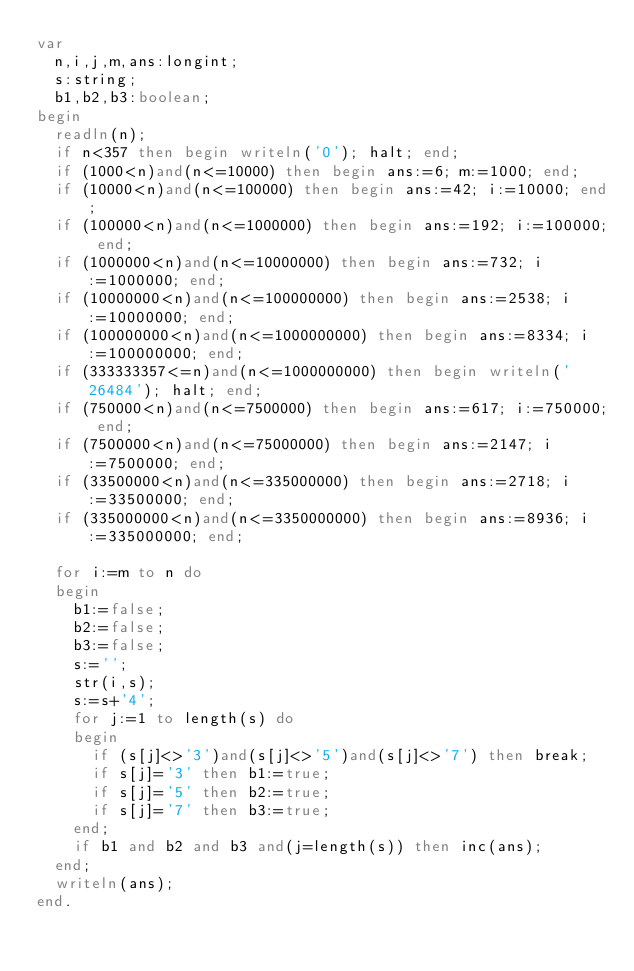Convert code to text. <code><loc_0><loc_0><loc_500><loc_500><_Pascal_>var
  n,i,j,m,ans:longint;
  s:string;
  b1,b2,b3:boolean;
begin
  readln(n);
  if n<357 then begin writeln('0'); halt; end;
  if (1000<n)and(n<=10000) then begin ans:=6; m:=1000; end;
  if (10000<n)and(n<=100000) then begin ans:=42; i:=10000; end;
  if (100000<n)and(n<=1000000) then begin ans:=192; i:=100000; end;
  if (1000000<n)and(n<=10000000) then begin ans:=732; i:=1000000; end;
  if (10000000<n)and(n<=100000000) then begin ans:=2538; i:=10000000; end;
  if (100000000<n)and(n<=1000000000) then begin ans:=8334; i:=100000000; end;
  if (333333357<=n)and(n<=1000000000) then begin writeln('26484'); halt; end;
  if (750000<n)and(n<=7500000) then begin ans:=617; i:=750000; end;
  if (7500000<n)and(n<=75000000) then begin ans:=2147; i:=7500000; end;
  if (33500000<n)and(n<=335000000) then begin ans:=2718; i:=33500000; end;
  if (335000000<n)and(n<=3350000000) then begin ans:=8936; i:=335000000; end;

  for i:=m to n do
  begin
    b1:=false;
    b2:=false;
    b3:=false;
    s:='';
	str(i,s);
    s:=s+'4';
    for j:=1 to length(s) do 
    begin 
      if (s[j]<>'3')and(s[j]<>'5')and(s[j]<>'7') then break;
      if s[j]='3' then b1:=true;
      if s[j]='5' then b2:=true;
      if s[j]='7' then b3:=true;
    end;
    if b1 and b2 and b3 and(j=length(s)) then inc(ans);
  end;
  writeln(ans);
end.</code> 